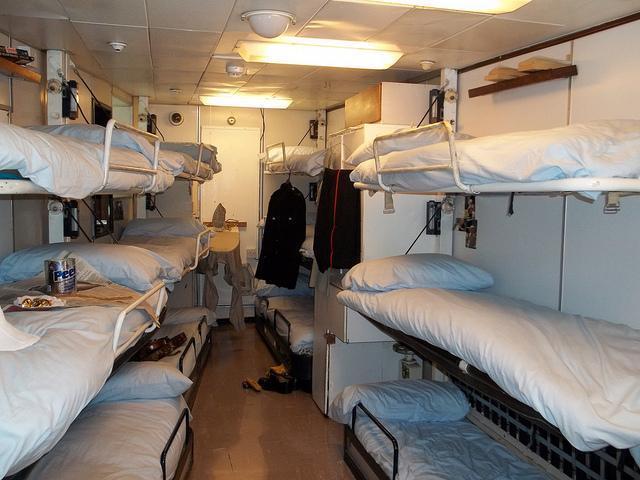Who likely resides here?
Select the correct answer and articulate reasoning with the following format: 'Answer: answer
Rationale: rationale.'
Options: Newlywed couple, army trainees, bachelor, two roommates. Answer: army trainees.
Rationale: This scene appears to be bunk beds or barracks so naturally i would think it would house some form of military. 